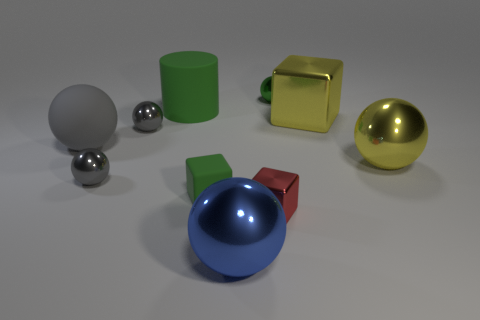Subtract all shiny cubes. How many cubes are left? 1 Subtract all cylinders. How many objects are left? 9 Subtract 4 spheres. How many spheres are left? 2 Subtract all brown balls. Subtract all green blocks. How many balls are left? 6 Subtract all purple spheres. How many yellow blocks are left? 1 Subtract all red metal objects. Subtract all matte cylinders. How many objects are left? 8 Add 5 large rubber balls. How many large rubber balls are left? 6 Add 8 small gray balls. How many small gray balls exist? 10 Subtract all gray balls. How many balls are left? 3 Subtract 0 cyan spheres. How many objects are left? 10 